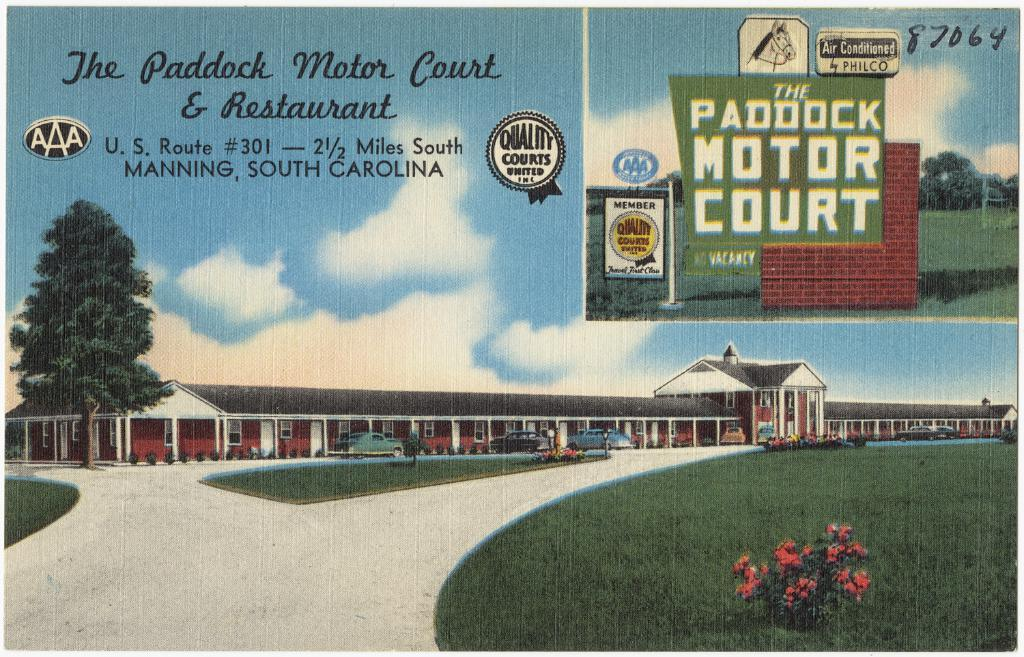Provide a one-sentence caption for the provided image. A vintage looking advertisement promotes The Paddock Motor Court & Restaurant. 